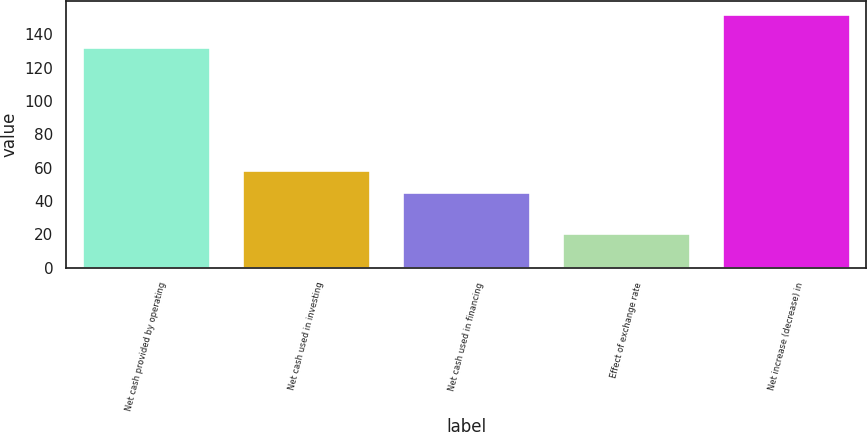Convert chart to OTSL. <chart><loc_0><loc_0><loc_500><loc_500><bar_chart><fcel>Net cash provided by operating<fcel>Net cash used in investing<fcel>Net cash used in financing<fcel>Effect of exchange rate<fcel>Net increase (decrease) in<nl><fcel>132.3<fcel>58.86<fcel>45.7<fcel>20.6<fcel>152.2<nl></chart> 